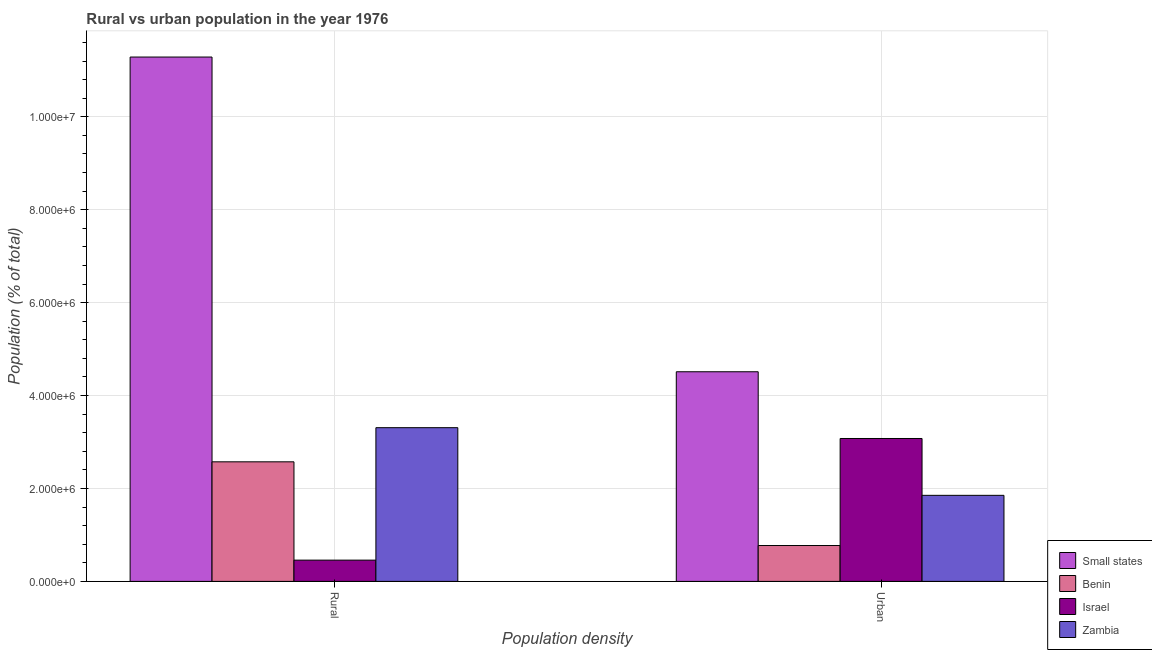Are the number of bars on each tick of the X-axis equal?
Offer a terse response. Yes. How many bars are there on the 1st tick from the left?
Your answer should be very brief. 4. What is the label of the 2nd group of bars from the left?
Offer a very short reply. Urban. What is the rural population density in Small states?
Keep it short and to the point. 1.13e+07. Across all countries, what is the maximum rural population density?
Ensure brevity in your answer.  1.13e+07. Across all countries, what is the minimum urban population density?
Provide a succinct answer. 7.72e+05. In which country was the urban population density maximum?
Provide a succinct answer. Small states. In which country was the rural population density minimum?
Provide a succinct answer. Israel. What is the total rural population density in the graph?
Your answer should be very brief. 1.76e+07. What is the difference between the rural population density in Zambia and that in Small states?
Keep it short and to the point. -7.98e+06. What is the difference between the rural population density in Israel and the urban population density in Small states?
Provide a succinct answer. -4.05e+06. What is the average urban population density per country?
Give a very brief answer. 2.55e+06. What is the difference between the rural population density and urban population density in Benin?
Offer a very short reply. 1.80e+06. What is the ratio of the rural population density in Zambia to that in Benin?
Provide a succinct answer. 1.29. Is the rural population density in Small states less than that in Zambia?
Provide a succinct answer. No. In how many countries, is the urban population density greater than the average urban population density taken over all countries?
Offer a terse response. 2. What does the 3rd bar from the right in Rural represents?
Keep it short and to the point. Benin. How many bars are there?
Offer a terse response. 8. Are all the bars in the graph horizontal?
Ensure brevity in your answer.  No. Does the graph contain any zero values?
Keep it short and to the point. No. Does the graph contain grids?
Provide a succinct answer. Yes. What is the title of the graph?
Your answer should be compact. Rural vs urban population in the year 1976. What is the label or title of the X-axis?
Offer a terse response. Population density. What is the label or title of the Y-axis?
Give a very brief answer. Population (% of total). What is the Population (% of total) of Small states in Rural?
Your answer should be very brief. 1.13e+07. What is the Population (% of total) in Benin in Rural?
Provide a succinct answer. 2.57e+06. What is the Population (% of total) of Israel in Rural?
Your answer should be very brief. 4.57e+05. What is the Population (% of total) of Zambia in Rural?
Keep it short and to the point. 3.31e+06. What is the Population (% of total) in Small states in Urban?
Ensure brevity in your answer.  4.51e+06. What is the Population (% of total) in Benin in Urban?
Give a very brief answer. 7.72e+05. What is the Population (% of total) in Israel in Urban?
Ensure brevity in your answer.  3.08e+06. What is the Population (% of total) of Zambia in Urban?
Keep it short and to the point. 1.85e+06. Across all Population density, what is the maximum Population (% of total) in Small states?
Your answer should be very brief. 1.13e+07. Across all Population density, what is the maximum Population (% of total) of Benin?
Your answer should be very brief. 2.57e+06. Across all Population density, what is the maximum Population (% of total) of Israel?
Provide a short and direct response. 3.08e+06. Across all Population density, what is the maximum Population (% of total) of Zambia?
Your response must be concise. 3.31e+06. Across all Population density, what is the minimum Population (% of total) of Small states?
Your answer should be very brief. 4.51e+06. Across all Population density, what is the minimum Population (% of total) of Benin?
Your answer should be very brief. 7.72e+05. Across all Population density, what is the minimum Population (% of total) in Israel?
Make the answer very short. 4.57e+05. Across all Population density, what is the minimum Population (% of total) in Zambia?
Provide a short and direct response. 1.85e+06. What is the total Population (% of total) of Small states in the graph?
Your answer should be compact. 1.58e+07. What is the total Population (% of total) in Benin in the graph?
Keep it short and to the point. 3.35e+06. What is the total Population (% of total) of Israel in the graph?
Keep it short and to the point. 3.53e+06. What is the total Population (% of total) of Zambia in the graph?
Provide a short and direct response. 5.16e+06. What is the difference between the Population (% of total) of Small states in Rural and that in Urban?
Offer a terse response. 6.77e+06. What is the difference between the Population (% of total) of Benin in Rural and that in Urban?
Offer a very short reply. 1.80e+06. What is the difference between the Population (% of total) of Israel in Rural and that in Urban?
Keep it short and to the point. -2.62e+06. What is the difference between the Population (% of total) of Zambia in Rural and that in Urban?
Keep it short and to the point. 1.46e+06. What is the difference between the Population (% of total) of Small states in Rural and the Population (% of total) of Benin in Urban?
Your response must be concise. 1.05e+07. What is the difference between the Population (% of total) of Small states in Rural and the Population (% of total) of Israel in Urban?
Make the answer very short. 8.21e+06. What is the difference between the Population (% of total) in Small states in Rural and the Population (% of total) in Zambia in Urban?
Make the answer very short. 9.43e+06. What is the difference between the Population (% of total) of Benin in Rural and the Population (% of total) of Israel in Urban?
Provide a short and direct response. -5.02e+05. What is the difference between the Population (% of total) of Benin in Rural and the Population (% of total) of Zambia in Urban?
Offer a terse response. 7.21e+05. What is the difference between the Population (% of total) of Israel in Rural and the Population (% of total) of Zambia in Urban?
Give a very brief answer. -1.39e+06. What is the average Population (% of total) of Small states per Population density?
Keep it short and to the point. 7.90e+06. What is the average Population (% of total) in Benin per Population density?
Give a very brief answer. 1.67e+06. What is the average Population (% of total) in Israel per Population density?
Offer a very short reply. 1.77e+06. What is the average Population (% of total) in Zambia per Population density?
Your answer should be very brief. 2.58e+06. What is the difference between the Population (% of total) in Small states and Population (% of total) in Benin in Rural?
Make the answer very short. 8.71e+06. What is the difference between the Population (% of total) of Small states and Population (% of total) of Israel in Rural?
Keep it short and to the point. 1.08e+07. What is the difference between the Population (% of total) of Small states and Population (% of total) of Zambia in Rural?
Provide a succinct answer. 7.98e+06. What is the difference between the Population (% of total) in Benin and Population (% of total) in Israel in Rural?
Your answer should be very brief. 2.12e+06. What is the difference between the Population (% of total) in Benin and Population (% of total) in Zambia in Rural?
Give a very brief answer. -7.35e+05. What is the difference between the Population (% of total) of Israel and Population (% of total) of Zambia in Rural?
Offer a very short reply. -2.85e+06. What is the difference between the Population (% of total) in Small states and Population (% of total) in Benin in Urban?
Your response must be concise. 3.74e+06. What is the difference between the Population (% of total) in Small states and Population (% of total) in Israel in Urban?
Your answer should be compact. 1.44e+06. What is the difference between the Population (% of total) in Small states and Population (% of total) in Zambia in Urban?
Give a very brief answer. 2.66e+06. What is the difference between the Population (% of total) in Benin and Population (% of total) in Israel in Urban?
Provide a short and direct response. -2.30e+06. What is the difference between the Population (% of total) of Benin and Population (% of total) of Zambia in Urban?
Provide a succinct answer. -1.08e+06. What is the difference between the Population (% of total) of Israel and Population (% of total) of Zambia in Urban?
Provide a succinct answer. 1.22e+06. What is the ratio of the Population (% of total) in Small states in Rural to that in Urban?
Ensure brevity in your answer.  2.5. What is the ratio of the Population (% of total) of Benin in Rural to that in Urban?
Offer a very short reply. 3.33. What is the ratio of the Population (% of total) in Israel in Rural to that in Urban?
Keep it short and to the point. 0.15. What is the ratio of the Population (% of total) in Zambia in Rural to that in Urban?
Your answer should be compact. 1.79. What is the difference between the highest and the second highest Population (% of total) of Small states?
Give a very brief answer. 6.77e+06. What is the difference between the highest and the second highest Population (% of total) of Benin?
Offer a terse response. 1.80e+06. What is the difference between the highest and the second highest Population (% of total) in Israel?
Offer a terse response. 2.62e+06. What is the difference between the highest and the second highest Population (% of total) of Zambia?
Keep it short and to the point. 1.46e+06. What is the difference between the highest and the lowest Population (% of total) in Small states?
Your answer should be very brief. 6.77e+06. What is the difference between the highest and the lowest Population (% of total) of Benin?
Give a very brief answer. 1.80e+06. What is the difference between the highest and the lowest Population (% of total) in Israel?
Make the answer very short. 2.62e+06. What is the difference between the highest and the lowest Population (% of total) of Zambia?
Make the answer very short. 1.46e+06. 